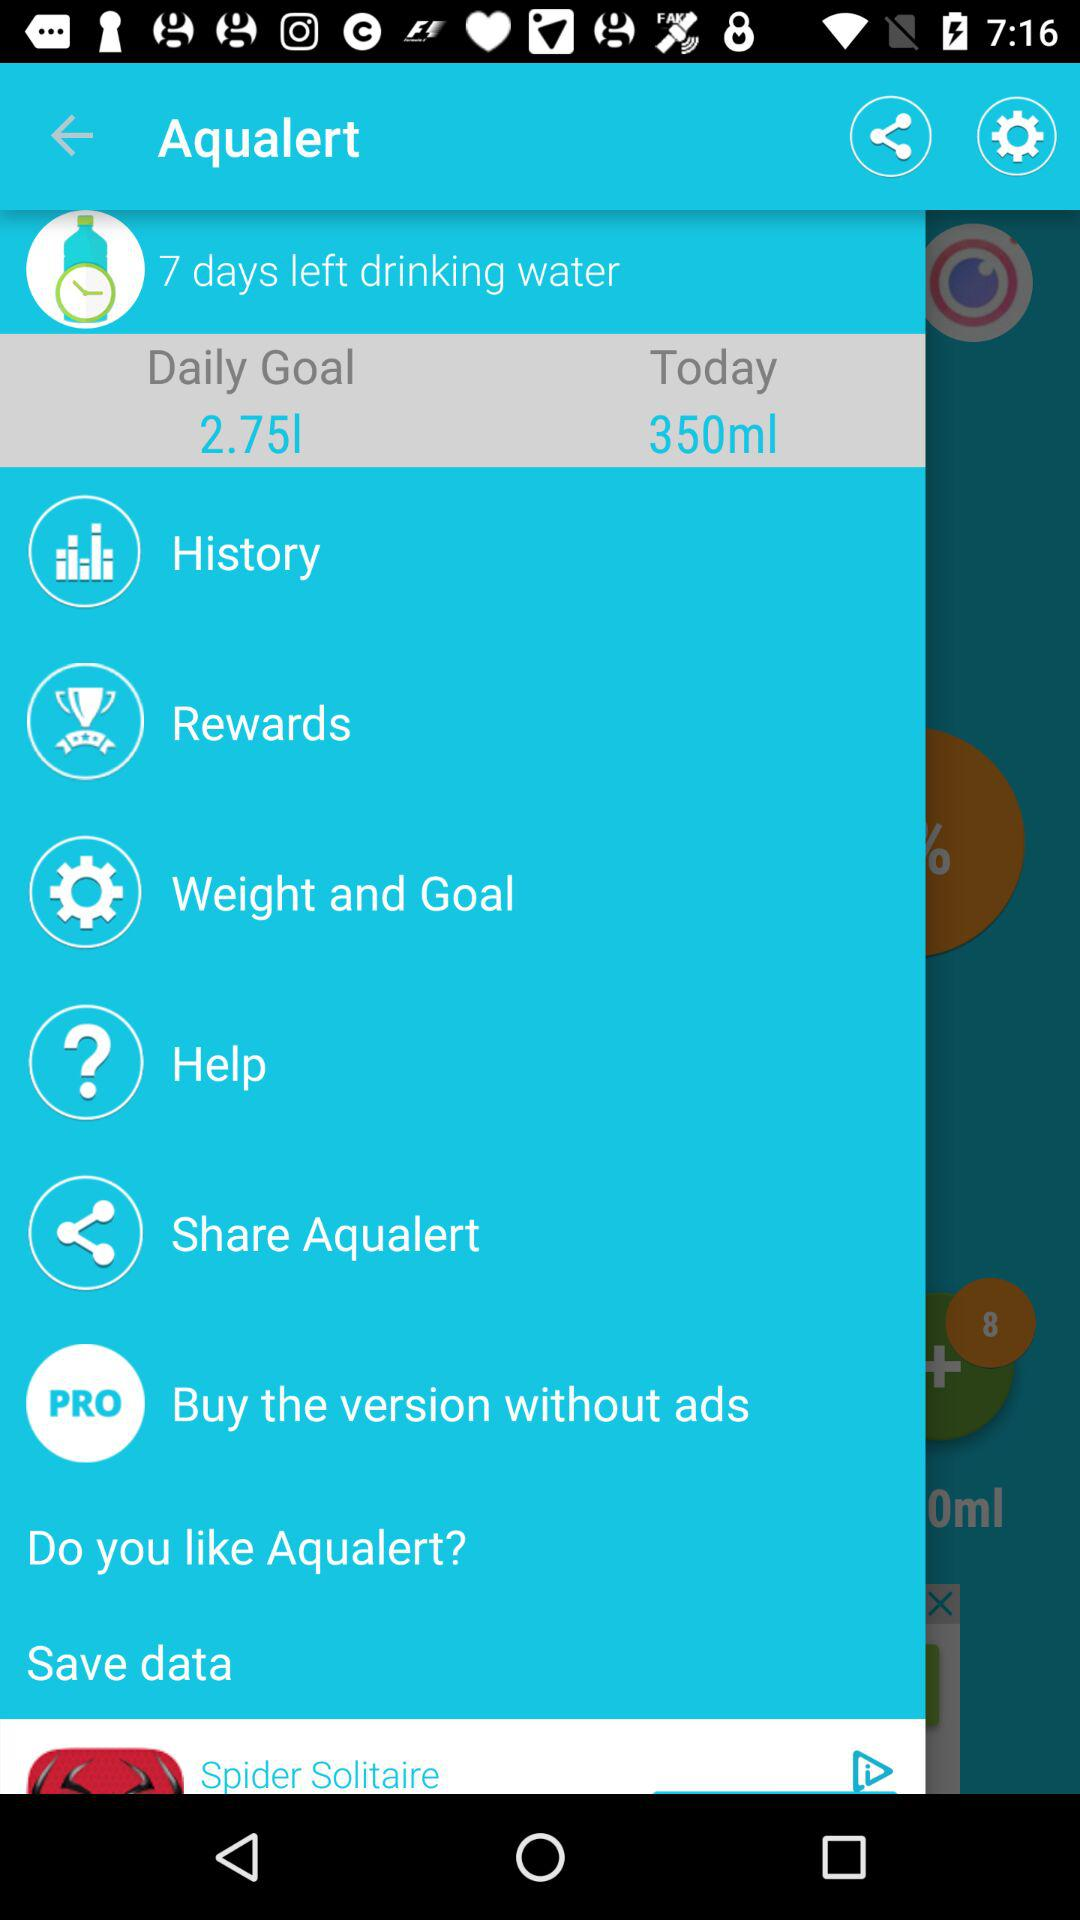What is the daily goal? The daily goal is to drink 2.75 liters of water. 